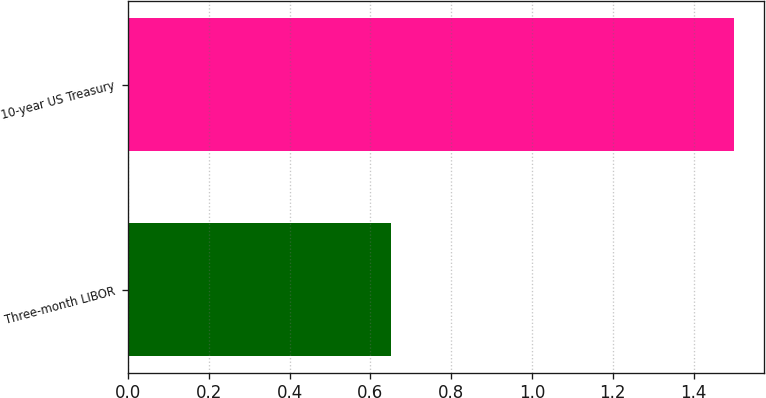<chart> <loc_0><loc_0><loc_500><loc_500><bar_chart><fcel>Three-month LIBOR<fcel>10-year US Treasury<nl><fcel>0.65<fcel>1.5<nl></chart> 